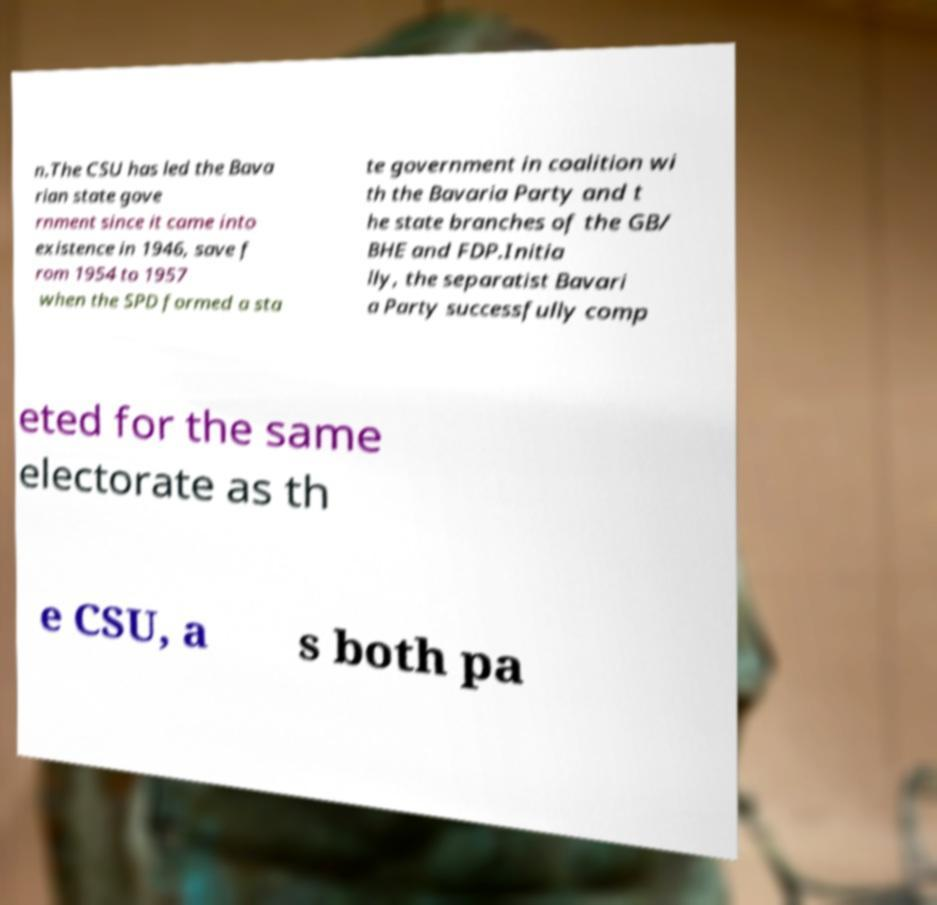What messages or text are displayed in this image? I need them in a readable, typed format. n.The CSU has led the Bava rian state gove rnment since it came into existence in 1946, save f rom 1954 to 1957 when the SPD formed a sta te government in coalition wi th the Bavaria Party and t he state branches of the GB/ BHE and FDP.Initia lly, the separatist Bavari a Party successfully comp eted for the same electorate as th e CSU, a s both pa 